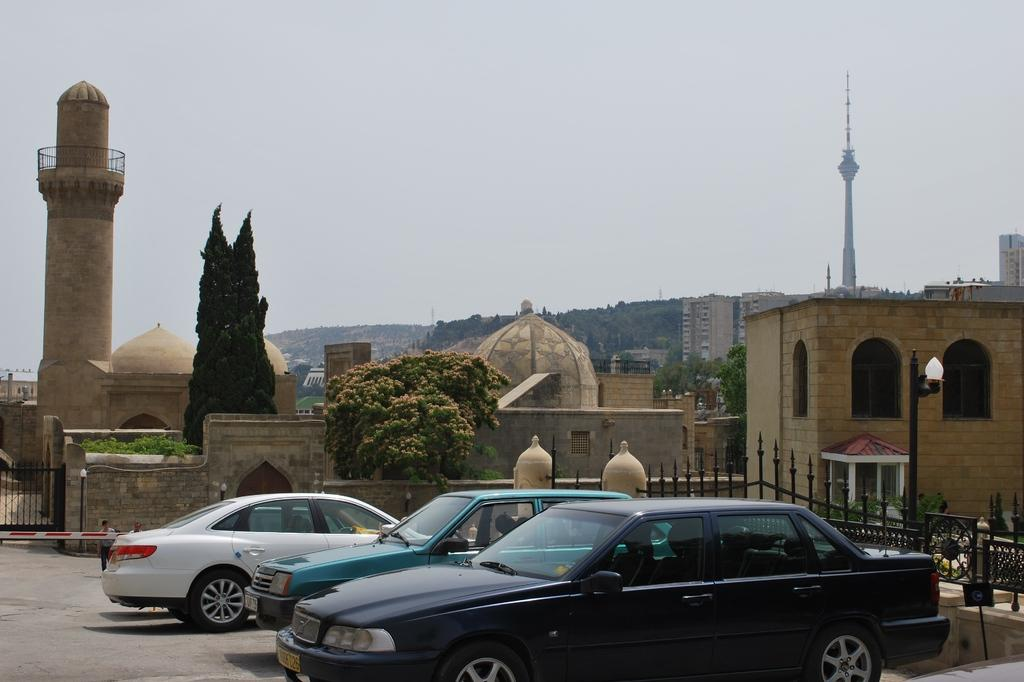What type of vehicles can be seen in the image? There are cars in the image. What is located behind the cars? There is a metal rod fence behind the cars. What type of street furniture is visible in the image? Lamp posts are visible in the image. What type of vegetation is present in the image? Trees are present in the image. What type of structures can be seen in the image? There are buildings in the image. What type of natural landform is visible in the image? Mountains are visible in the image. What type of lettuce is being used to decorate the lamp posts in the image? There is no lettuce present in the image, and the lamp posts are not being decorated with any vegetable. 